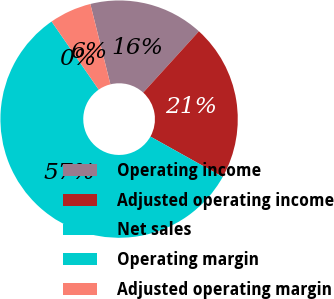Convert chart. <chart><loc_0><loc_0><loc_500><loc_500><pie_chart><fcel>Operating income<fcel>Adjusted operating income<fcel>Net sales<fcel>Operating margin<fcel>Adjusted operating margin<nl><fcel>15.64%<fcel>21.36%<fcel>57.27%<fcel>0.0%<fcel>5.73%<nl></chart> 